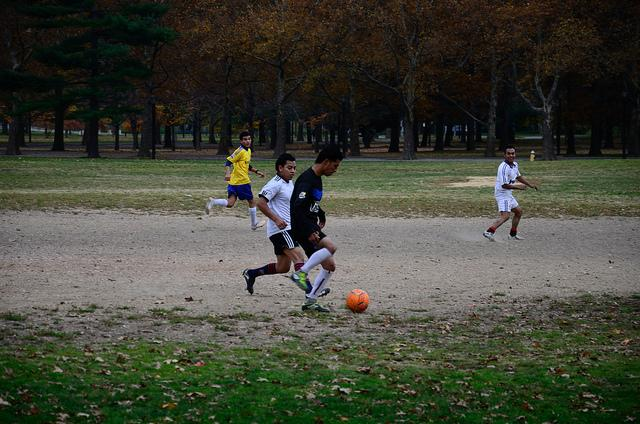What are the boys doing with the orange ball?

Choices:
A) painting it
B) dribbling it
C) throwing it
D) kicking it kicking it 